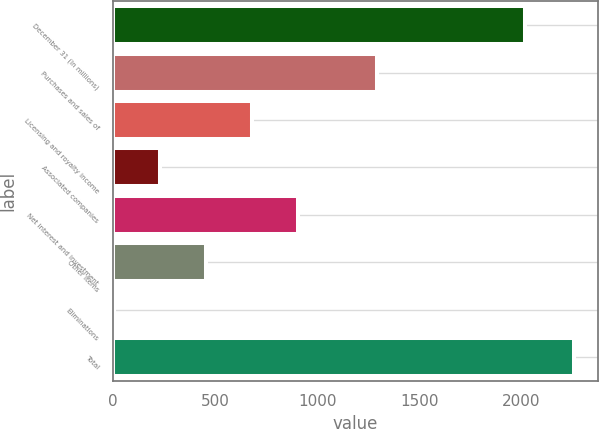<chart> <loc_0><loc_0><loc_500><loc_500><bar_chart><fcel>December 31 (In millions)<fcel>Purchases and sales of<fcel>Licensing and royalty income<fcel>Associated companies<fcel>Net interest and investment<fcel>Other items<fcel>Eliminations<fcel>Total<nl><fcel>2018<fcel>1294<fcel>680.5<fcel>229.5<fcel>906<fcel>455<fcel>4<fcel>2259<nl></chart> 